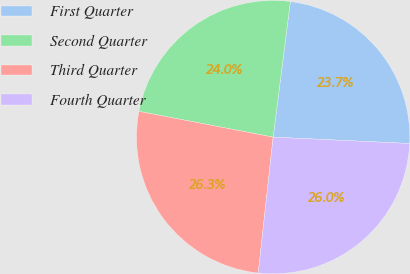Convert chart. <chart><loc_0><loc_0><loc_500><loc_500><pie_chart><fcel>First Quarter<fcel>Second Quarter<fcel>Third Quarter<fcel>Fourth Quarter<nl><fcel>23.73%<fcel>23.99%<fcel>26.28%<fcel>26.0%<nl></chart> 